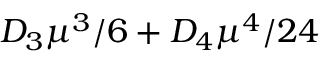<formula> <loc_0><loc_0><loc_500><loc_500>D _ { 3 } \mu ^ { 3 } / 6 + D _ { 4 } \mu ^ { 4 } / 2 4</formula> 